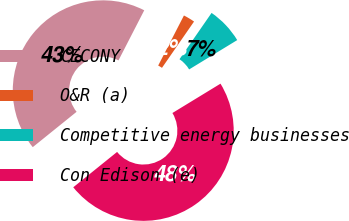Convert chart to OTSL. <chart><loc_0><loc_0><loc_500><loc_500><pie_chart><fcel>CECONY<fcel>O&R (a)<fcel>Competitive energy businesses<fcel>Con Edison (e)<nl><fcel>43.36%<fcel>2.08%<fcel>6.64%<fcel>47.92%<nl></chart> 